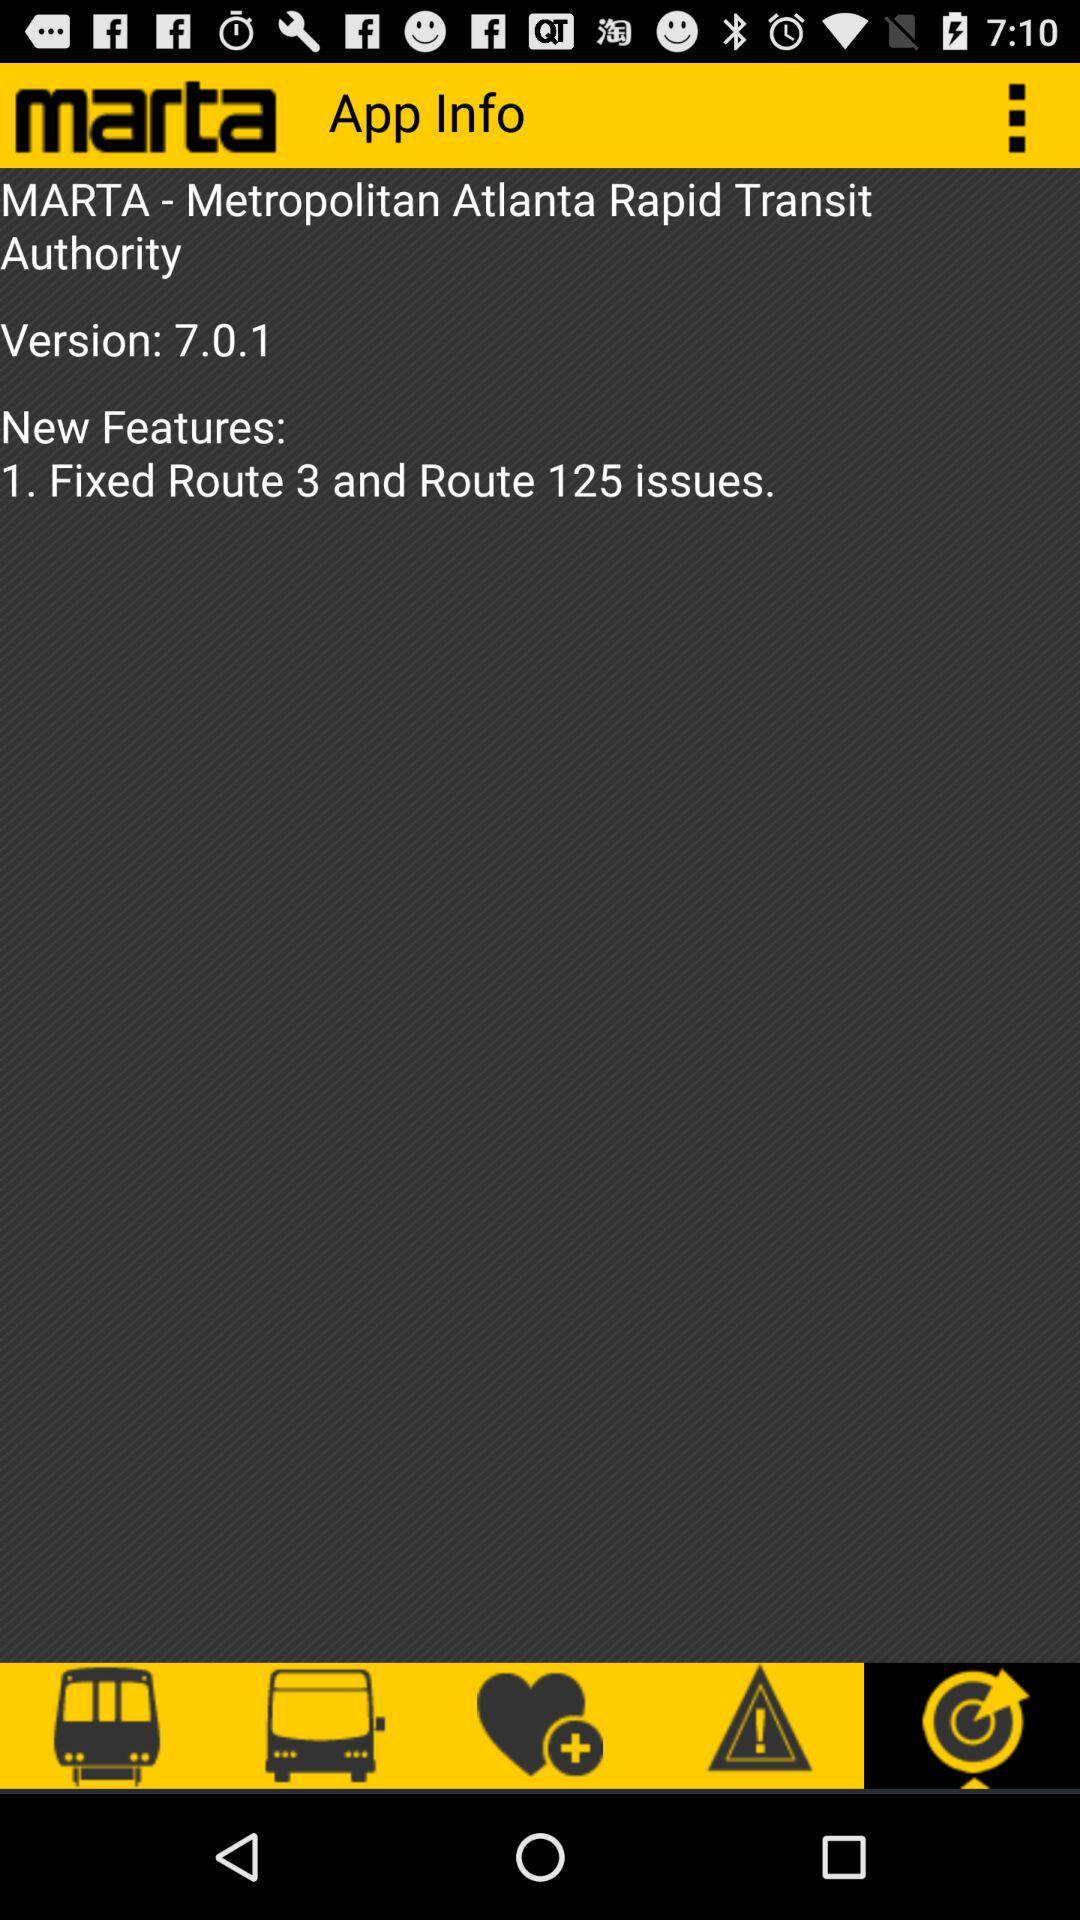What is the full form of MARTA? The full form of MARTA is Metropolitan Atlanta Rapid Transit Authority. 